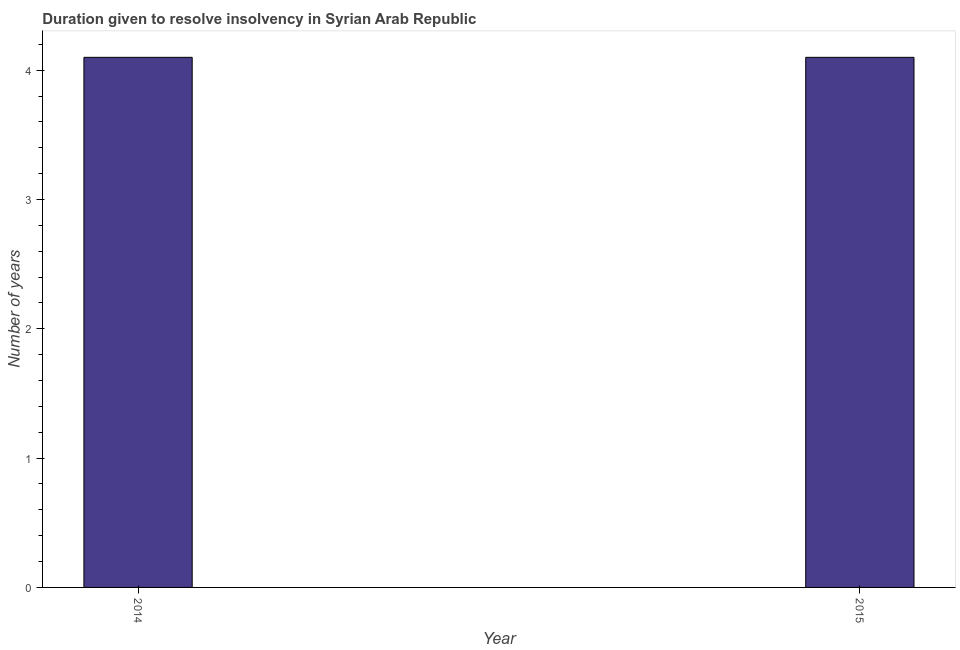Does the graph contain grids?
Offer a terse response. No. What is the title of the graph?
Offer a very short reply. Duration given to resolve insolvency in Syrian Arab Republic. What is the label or title of the Y-axis?
Ensure brevity in your answer.  Number of years. Across all years, what is the minimum number of years to resolve insolvency?
Your answer should be compact. 4.1. In which year was the number of years to resolve insolvency maximum?
Make the answer very short. 2014. What is the sum of the number of years to resolve insolvency?
Offer a terse response. 8.2. What is the difference between the number of years to resolve insolvency in 2014 and 2015?
Make the answer very short. 0. Do a majority of the years between 2015 and 2014 (inclusive) have number of years to resolve insolvency greater than 3 ?
Make the answer very short. No. Is the number of years to resolve insolvency in 2014 less than that in 2015?
Offer a very short reply. No. Are the values on the major ticks of Y-axis written in scientific E-notation?
Ensure brevity in your answer.  No. What is the Number of years in 2015?
Your answer should be very brief. 4.1. What is the difference between the Number of years in 2014 and 2015?
Provide a succinct answer. 0. What is the ratio of the Number of years in 2014 to that in 2015?
Your response must be concise. 1. 